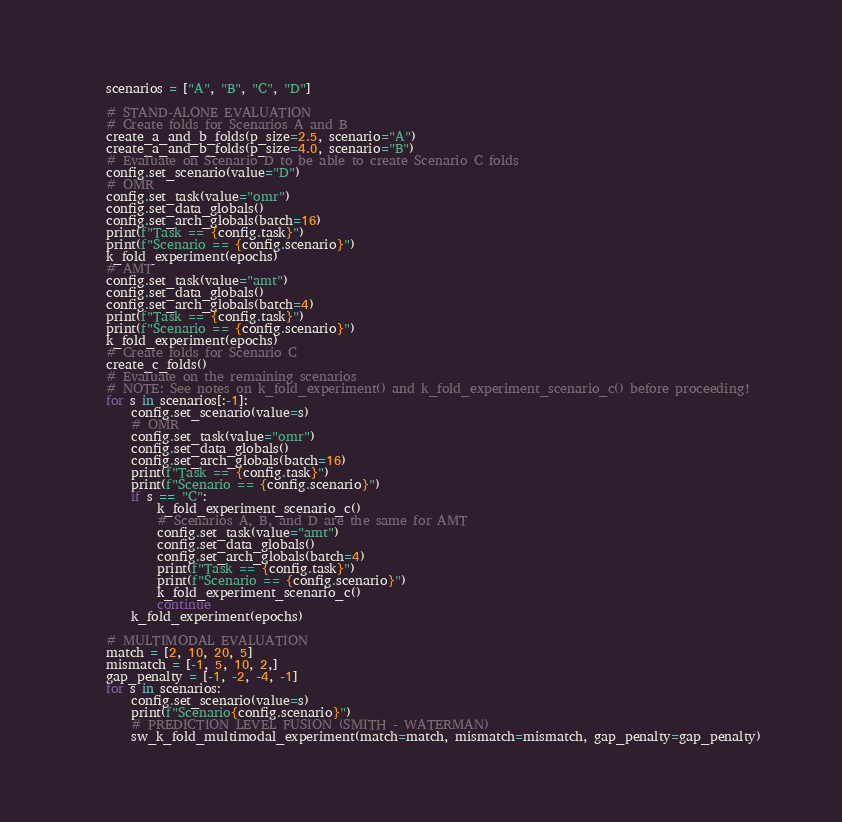<code> <loc_0><loc_0><loc_500><loc_500><_Python_>    scenarios = ["A", "B", "C", "D"]

    # STAND-ALONE EVALUATION
    # Create folds for Scenarios A and B
    create_a_and_b_folds(p_size=2.5, scenario="A")
    create_a_and_b_folds(p_size=4.0, scenario="B")
    # Evaluate on Scenario D to be able to create Scenario C folds
    config.set_scenario(value="D")
    # OMR
    config.set_task(value="omr")
    config.set_data_globals()
    config.set_arch_globals(batch=16)
    print(f"Task == {config.task}")
    print(f"Scenario == {config.scenario}")
    k_fold_experiment(epochs)
    # AMT
    config.set_task(value="amt")
    config.set_data_globals()
    config.set_arch_globals(batch=4)
    print(f"Task == {config.task}")
    print(f"Scenario == {config.scenario}")
    k_fold_experiment(epochs)
    # Create folds for Scenario C
    create_c_folds()
    # Evaluate on the remaining scenarios
    # NOTE: See notes on k_fold_experiment() and k_fold_experiment_scenario_c() before proceeding!
    for s in scenarios[:-1]:
        config.set_scenario(value=s)
        # OMR
        config.set_task(value="omr")
        config.set_data_globals()
        config.set_arch_globals(batch=16)
        print(f"Task == {config.task}")
        print(f"Scenario == {config.scenario}")
        if s == "C":
            k_fold_experiment_scenario_c()
            # Scenarios A, B, and D are the same for AMT
            config.set_task(value="amt")
            config.set_data_globals()
            config.set_arch_globals(batch=4)
            print(f"Task == {config.task}")
            print(f"Scenario == {config.scenario}")
            k_fold_experiment_scenario_c()
            continue
        k_fold_experiment(epochs)

    # MULTIMODAL EVALUATION
    match = [2, 10, 20, 5]
    mismatch = [-1, 5, 10, 2,]
    gap_penalty = [-1, -2, -4, -1]
    for s in scenarios:
        config.set_scenario(value=s)
        print(f"Scenario{config.scenario}")
        # PREDICTION LEVEL FUSION (SMITH - WATERMAN)
        sw_k_fold_multimodal_experiment(match=match, mismatch=mismatch, gap_penalty=gap_penalty)
</code> 